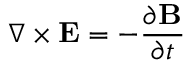<formula> <loc_0><loc_0><loc_500><loc_500>\nabla \times E = - { \frac { \partial B } { \partial t } }</formula> 